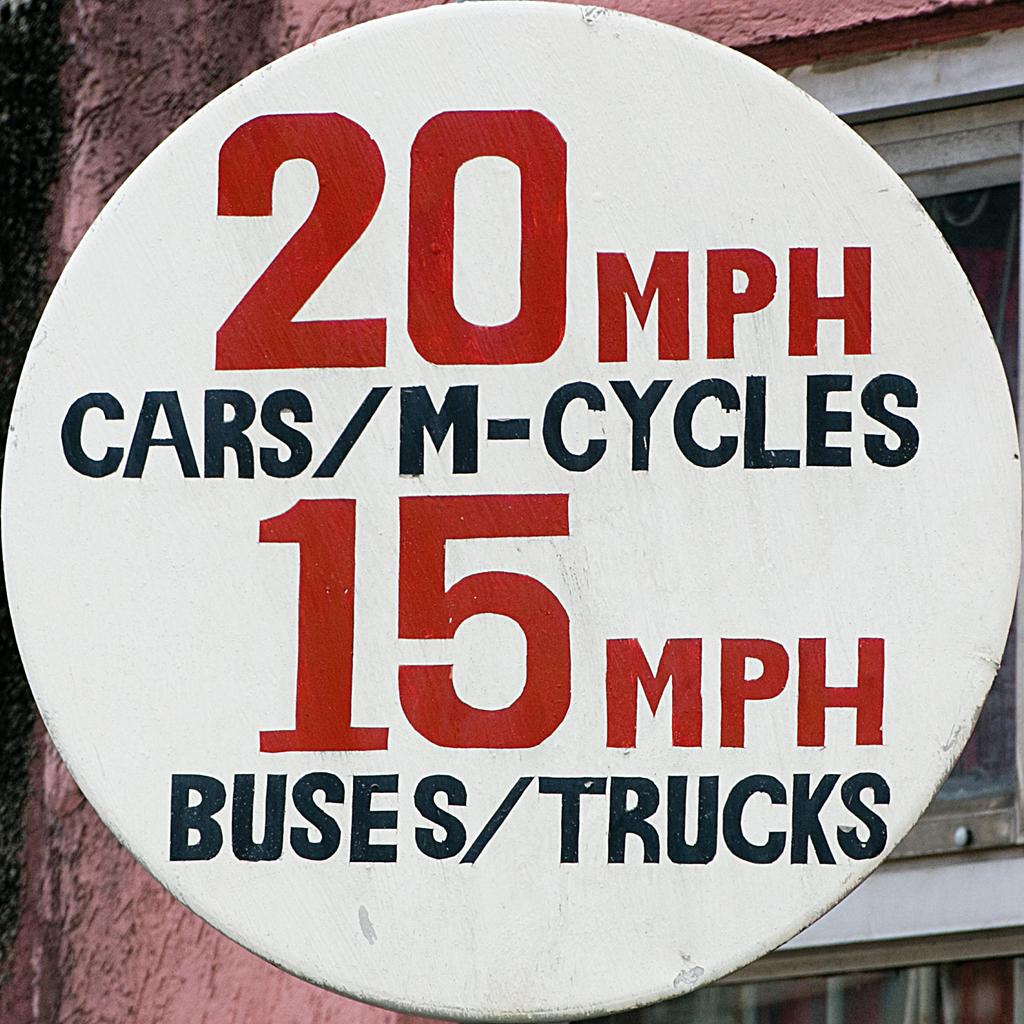What is the main object in the image? There is a sign board in the image. What is written on the sign board? There is writing on the sign board. What is the sign board attached to? There is a pole associated with the sign board. What is behind the pole? There is a wall behind the pole. What feature does the wall have? The wall has a glass window. What type of zinc is used to make the sign board in the image? There is no mention of zinc being used to make the sign board in the image. The sign board is made of other materials, such as metal or plastic, but not zinc. How does the sign board shake during a rainstorm in the image? There is no rainstorm depicted in the image, and the sign board is not shown shaking. 